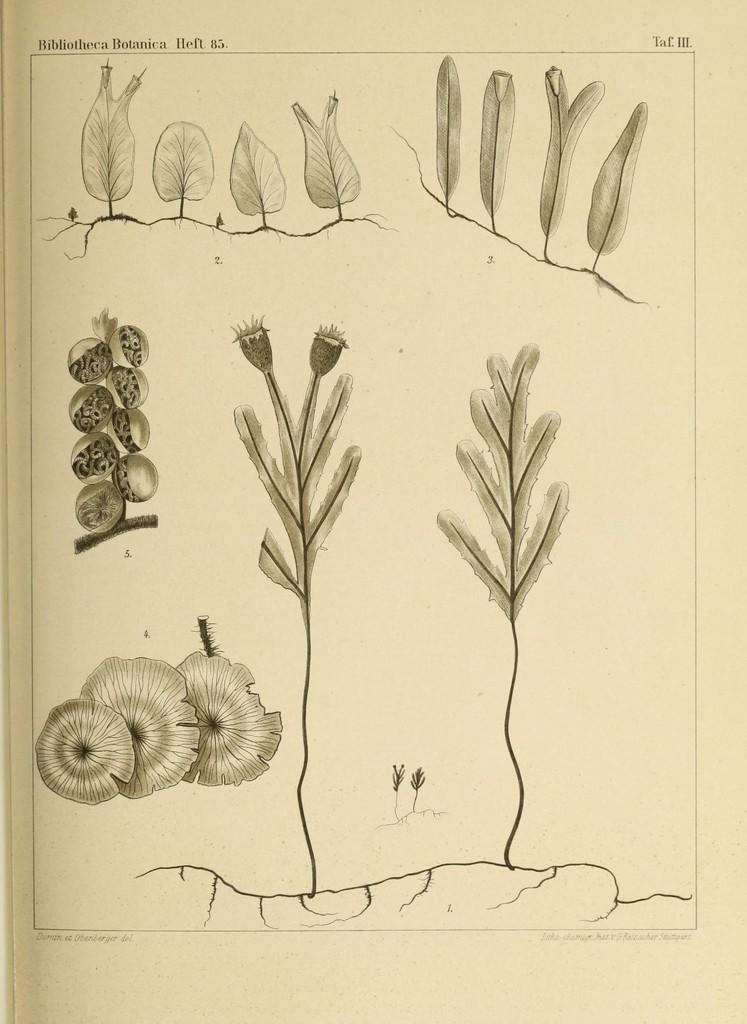What is depicted in the drawings in the image? The drawings in the image are of plants. What material are the drawings on? The drawings are on a paper. What type of copper material is used to create the drawings in the image? There is no copper material mentioned or visible in the image; the drawings are on paper. How many bikes are depicted in the drawings in the image? There are no bikes depicted in the drawings in the image; the drawings are of plants. 